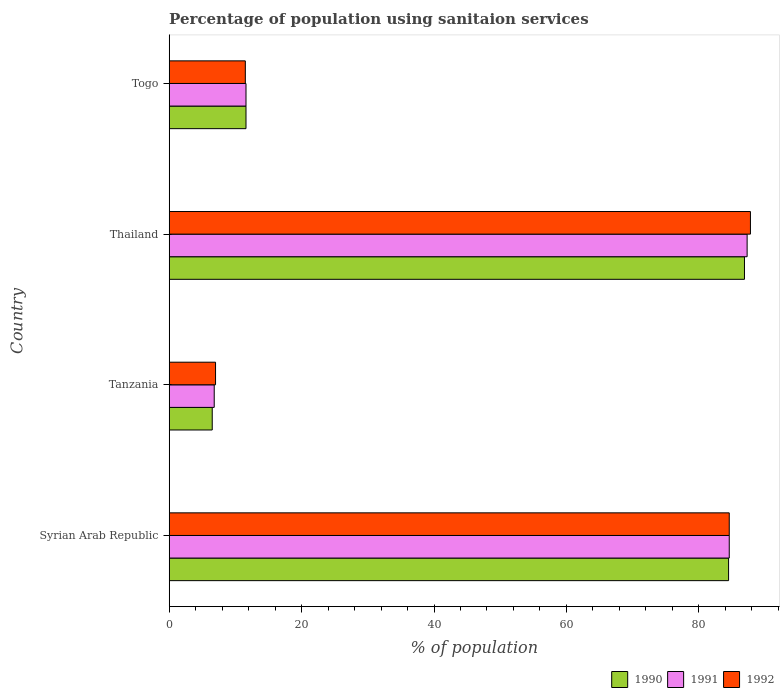How many different coloured bars are there?
Provide a succinct answer. 3. How many bars are there on the 4th tick from the top?
Give a very brief answer. 3. What is the label of the 4th group of bars from the top?
Keep it short and to the point. Syrian Arab Republic. Across all countries, what is the maximum percentage of population using sanitaion services in 1990?
Give a very brief answer. 86.9. In which country was the percentage of population using sanitaion services in 1990 maximum?
Your answer should be very brief. Thailand. In which country was the percentage of population using sanitaion services in 1990 minimum?
Your response must be concise. Tanzania. What is the total percentage of population using sanitaion services in 1992 in the graph?
Make the answer very short. 190.9. What is the difference between the percentage of population using sanitaion services in 1992 in Syrian Arab Republic and that in Thailand?
Your response must be concise. -3.2. What is the average percentage of population using sanitaion services in 1991 per country?
Your response must be concise. 47.57. What is the difference between the percentage of population using sanitaion services in 1992 and percentage of population using sanitaion services in 1990 in Syrian Arab Republic?
Your answer should be very brief. 0.1. What is the ratio of the percentage of population using sanitaion services in 1992 in Tanzania to that in Togo?
Ensure brevity in your answer.  0.61. Is the difference between the percentage of population using sanitaion services in 1992 in Syrian Arab Republic and Togo greater than the difference between the percentage of population using sanitaion services in 1990 in Syrian Arab Republic and Togo?
Your response must be concise. Yes. What is the difference between the highest and the second highest percentage of population using sanitaion services in 1992?
Your response must be concise. 3.2. What is the difference between the highest and the lowest percentage of population using sanitaion services in 1990?
Offer a terse response. 80.4. In how many countries, is the percentage of population using sanitaion services in 1990 greater than the average percentage of population using sanitaion services in 1990 taken over all countries?
Your response must be concise. 2. Is the sum of the percentage of population using sanitaion services in 1991 in Syrian Arab Republic and Togo greater than the maximum percentage of population using sanitaion services in 1990 across all countries?
Offer a terse response. Yes. How many bars are there?
Your response must be concise. 12. What is the difference between two consecutive major ticks on the X-axis?
Make the answer very short. 20. Where does the legend appear in the graph?
Keep it short and to the point. Bottom right. How many legend labels are there?
Your response must be concise. 3. How are the legend labels stacked?
Provide a succinct answer. Horizontal. What is the title of the graph?
Keep it short and to the point. Percentage of population using sanitaion services. What is the label or title of the X-axis?
Make the answer very short. % of population. What is the label or title of the Y-axis?
Ensure brevity in your answer.  Country. What is the % of population in 1990 in Syrian Arab Republic?
Your answer should be very brief. 84.5. What is the % of population in 1991 in Syrian Arab Republic?
Keep it short and to the point. 84.6. What is the % of population in 1992 in Syrian Arab Republic?
Your response must be concise. 84.6. What is the % of population in 1990 in Tanzania?
Make the answer very short. 6.5. What is the % of population of 1992 in Tanzania?
Ensure brevity in your answer.  7. What is the % of population in 1990 in Thailand?
Ensure brevity in your answer.  86.9. What is the % of population of 1991 in Thailand?
Your answer should be compact. 87.3. What is the % of population of 1992 in Thailand?
Keep it short and to the point. 87.8. What is the % of population of 1990 in Togo?
Your answer should be very brief. 11.6. What is the % of population in 1991 in Togo?
Make the answer very short. 11.6. What is the % of population in 1992 in Togo?
Offer a very short reply. 11.5. Across all countries, what is the maximum % of population in 1990?
Make the answer very short. 86.9. Across all countries, what is the maximum % of population of 1991?
Your answer should be compact. 87.3. Across all countries, what is the maximum % of population of 1992?
Provide a short and direct response. 87.8. Across all countries, what is the minimum % of population in 1990?
Your answer should be very brief. 6.5. Across all countries, what is the minimum % of population in 1991?
Ensure brevity in your answer.  6.8. What is the total % of population in 1990 in the graph?
Provide a short and direct response. 189.5. What is the total % of population of 1991 in the graph?
Keep it short and to the point. 190.3. What is the total % of population in 1992 in the graph?
Offer a terse response. 190.9. What is the difference between the % of population of 1991 in Syrian Arab Republic and that in Tanzania?
Give a very brief answer. 77.8. What is the difference between the % of population in 1992 in Syrian Arab Republic and that in Tanzania?
Provide a short and direct response. 77.6. What is the difference between the % of population in 1990 in Syrian Arab Republic and that in Thailand?
Your answer should be compact. -2.4. What is the difference between the % of population in 1991 in Syrian Arab Republic and that in Thailand?
Your response must be concise. -2.7. What is the difference between the % of population of 1990 in Syrian Arab Republic and that in Togo?
Provide a succinct answer. 72.9. What is the difference between the % of population of 1992 in Syrian Arab Republic and that in Togo?
Keep it short and to the point. 73.1. What is the difference between the % of population in 1990 in Tanzania and that in Thailand?
Your answer should be very brief. -80.4. What is the difference between the % of population in 1991 in Tanzania and that in Thailand?
Give a very brief answer. -80.5. What is the difference between the % of population of 1992 in Tanzania and that in Thailand?
Give a very brief answer. -80.8. What is the difference between the % of population of 1990 in Thailand and that in Togo?
Give a very brief answer. 75.3. What is the difference between the % of population of 1991 in Thailand and that in Togo?
Your answer should be compact. 75.7. What is the difference between the % of population in 1992 in Thailand and that in Togo?
Ensure brevity in your answer.  76.3. What is the difference between the % of population in 1990 in Syrian Arab Republic and the % of population in 1991 in Tanzania?
Provide a succinct answer. 77.7. What is the difference between the % of population of 1990 in Syrian Arab Republic and the % of population of 1992 in Tanzania?
Offer a terse response. 77.5. What is the difference between the % of population of 1991 in Syrian Arab Republic and the % of population of 1992 in Tanzania?
Make the answer very short. 77.6. What is the difference between the % of population in 1990 in Syrian Arab Republic and the % of population in 1992 in Thailand?
Offer a very short reply. -3.3. What is the difference between the % of population of 1990 in Syrian Arab Republic and the % of population of 1991 in Togo?
Your answer should be compact. 72.9. What is the difference between the % of population in 1991 in Syrian Arab Republic and the % of population in 1992 in Togo?
Ensure brevity in your answer.  73.1. What is the difference between the % of population of 1990 in Tanzania and the % of population of 1991 in Thailand?
Your answer should be very brief. -80.8. What is the difference between the % of population in 1990 in Tanzania and the % of population in 1992 in Thailand?
Your answer should be compact. -81.3. What is the difference between the % of population of 1991 in Tanzania and the % of population of 1992 in Thailand?
Make the answer very short. -81. What is the difference between the % of population in 1990 in Thailand and the % of population in 1991 in Togo?
Your response must be concise. 75.3. What is the difference between the % of population in 1990 in Thailand and the % of population in 1992 in Togo?
Offer a terse response. 75.4. What is the difference between the % of population in 1991 in Thailand and the % of population in 1992 in Togo?
Provide a succinct answer. 75.8. What is the average % of population in 1990 per country?
Your response must be concise. 47.38. What is the average % of population of 1991 per country?
Offer a terse response. 47.58. What is the average % of population in 1992 per country?
Your response must be concise. 47.73. What is the difference between the % of population in 1990 and % of population in 1991 in Syrian Arab Republic?
Make the answer very short. -0.1. What is the difference between the % of population in 1990 and % of population in 1992 in Syrian Arab Republic?
Provide a succinct answer. -0.1. What is the difference between the % of population of 1991 and % of population of 1992 in Syrian Arab Republic?
Provide a succinct answer. 0. What is the difference between the % of population of 1990 and % of population of 1991 in Tanzania?
Your answer should be very brief. -0.3. What is the difference between the % of population in 1991 and % of population in 1992 in Tanzania?
Ensure brevity in your answer.  -0.2. What is the difference between the % of population of 1990 and % of population of 1991 in Thailand?
Offer a very short reply. -0.4. What is the difference between the % of population in 1990 and % of population in 1992 in Thailand?
Give a very brief answer. -0.9. What is the difference between the % of population in 1990 and % of population in 1992 in Togo?
Keep it short and to the point. 0.1. What is the ratio of the % of population in 1991 in Syrian Arab Republic to that in Tanzania?
Give a very brief answer. 12.44. What is the ratio of the % of population of 1992 in Syrian Arab Republic to that in Tanzania?
Provide a succinct answer. 12.09. What is the ratio of the % of population of 1990 in Syrian Arab Republic to that in Thailand?
Keep it short and to the point. 0.97. What is the ratio of the % of population of 1991 in Syrian Arab Republic to that in Thailand?
Provide a short and direct response. 0.97. What is the ratio of the % of population in 1992 in Syrian Arab Republic to that in Thailand?
Offer a very short reply. 0.96. What is the ratio of the % of population in 1990 in Syrian Arab Republic to that in Togo?
Your response must be concise. 7.28. What is the ratio of the % of population in 1991 in Syrian Arab Republic to that in Togo?
Provide a succinct answer. 7.29. What is the ratio of the % of population in 1992 in Syrian Arab Republic to that in Togo?
Your response must be concise. 7.36. What is the ratio of the % of population of 1990 in Tanzania to that in Thailand?
Offer a terse response. 0.07. What is the ratio of the % of population of 1991 in Tanzania to that in Thailand?
Your answer should be very brief. 0.08. What is the ratio of the % of population of 1992 in Tanzania to that in Thailand?
Give a very brief answer. 0.08. What is the ratio of the % of population of 1990 in Tanzania to that in Togo?
Ensure brevity in your answer.  0.56. What is the ratio of the % of population of 1991 in Tanzania to that in Togo?
Give a very brief answer. 0.59. What is the ratio of the % of population in 1992 in Tanzania to that in Togo?
Provide a succinct answer. 0.61. What is the ratio of the % of population in 1990 in Thailand to that in Togo?
Provide a short and direct response. 7.49. What is the ratio of the % of population of 1991 in Thailand to that in Togo?
Offer a terse response. 7.53. What is the ratio of the % of population in 1992 in Thailand to that in Togo?
Make the answer very short. 7.63. What is the difference between the highest and the second highest % of population of 1991?
Your response must be concise. 2.7. What is the difference between the highest and the second highest % of population in 1992?
Your answer should be compact. 3.2. What is the difference between the highest and the lowest % of population of 1990?
Your response must be concise. 80.4. What is the difference between the highest and the lowest % of population of 1991?
Keep it short and to the point. 80.5. What is the difference between the highest and the lowest % of population of 1992?
Your answer should be compact. 80.8. 